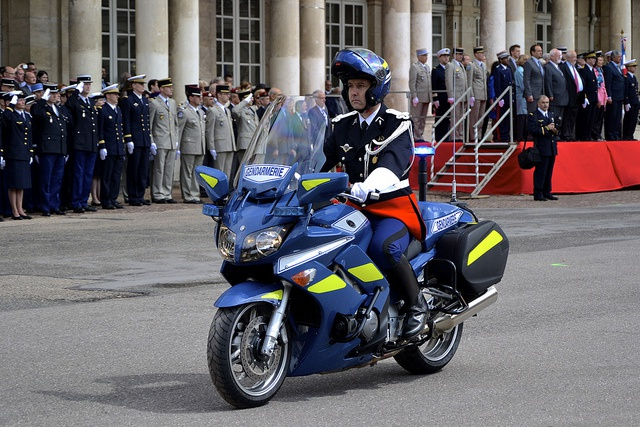Describe the objects in this image and their specific colors. I can see motorcycle in black, navy, and gray tones, people in black, gray, and darkgray tones, people in black, white, navy, and gray tones, people in black, navy, gray, and white tones, and people in black, gray, and darkgray tones in this image. 